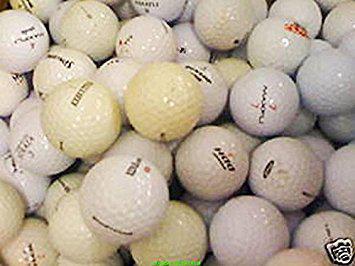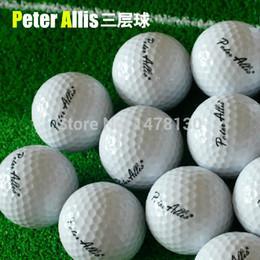The first image is the image on the left, the second image is the image on the right. For the images displayed, is the sentence "There are multiple golf balls in each image, and no visible containers." factually correct? Answer yes or no. Yes. 